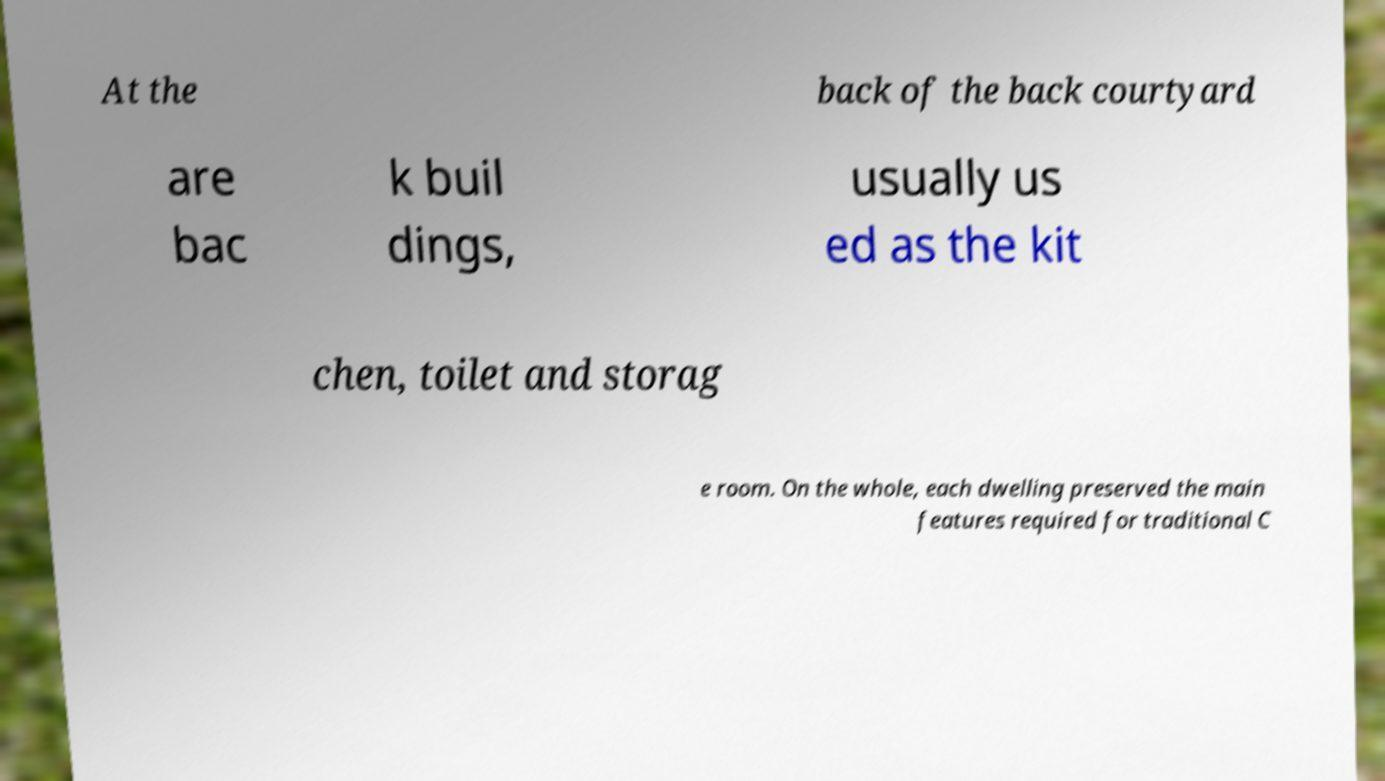Please read and relay the text visible in this image. What does it say? At the back of the back courtyard are bac k buil dings, usually us ed as the kit chen, toilet and storag e room. On the whole, each dwelling preserved the main features required for traditional C 